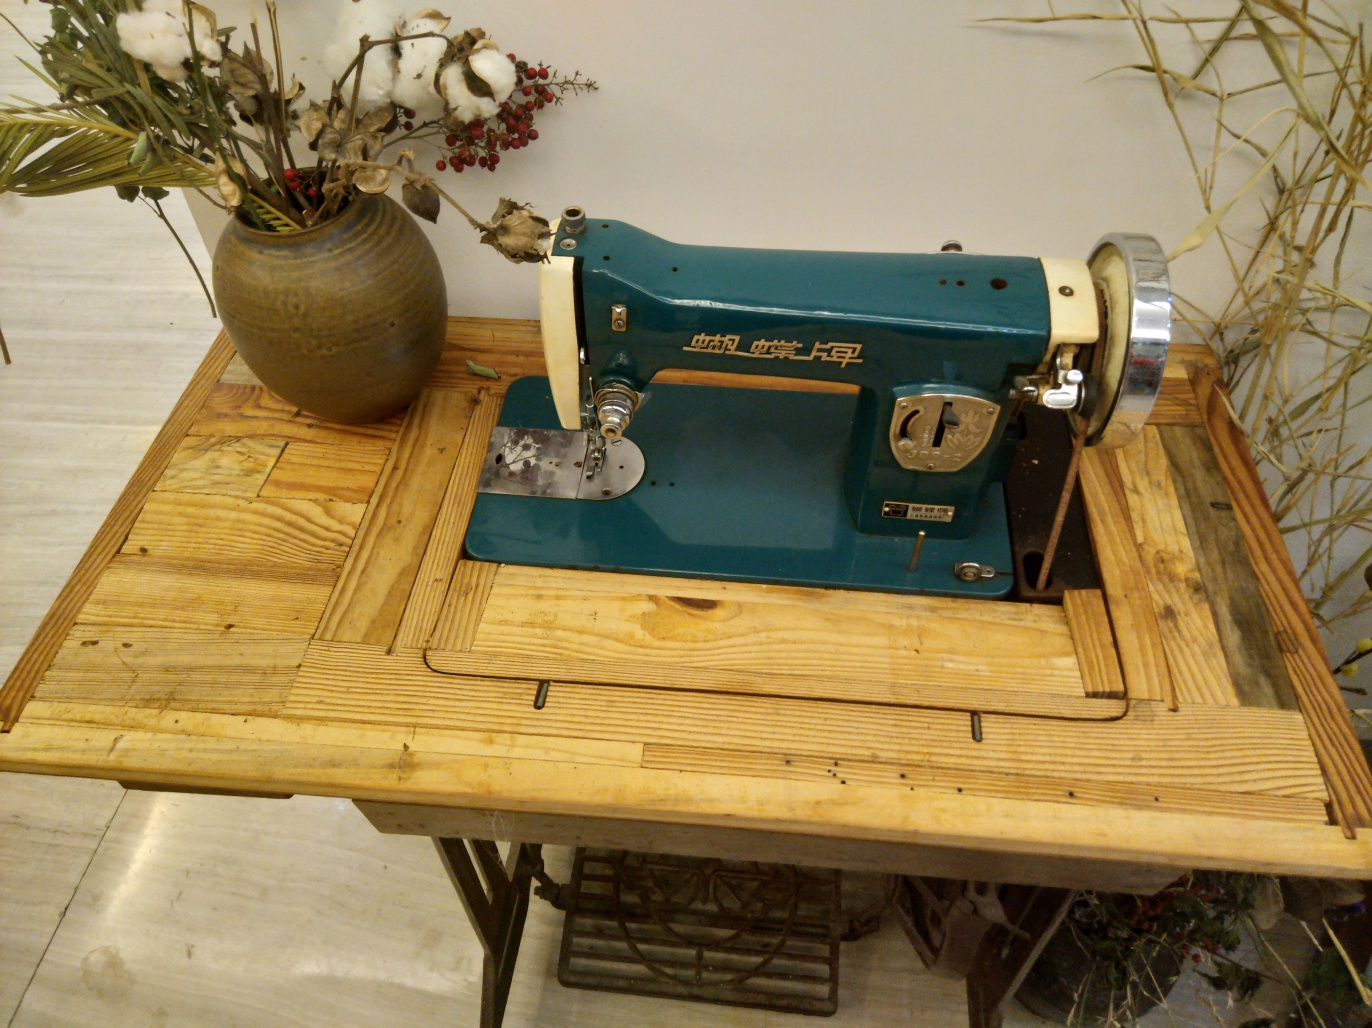Could you describe the materials and design elements seen on the table? Certainly! The table appears to be made of weathered pine wood, with its natural knots and grain patterns enhancing the rustic aesthetic. The design elements include an intriguing mix of straight and diagonal planks, creating a patchwork-like surface that complements the industrial vibe of the sewing machine. 